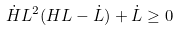Convert formula to latex. <formula><loc_0><loc_0><loc_500><loc_500>\dot { H } L ^ { 2 } ( H L - \dot { L } ) + \dot { L } \geq 0</formula> 